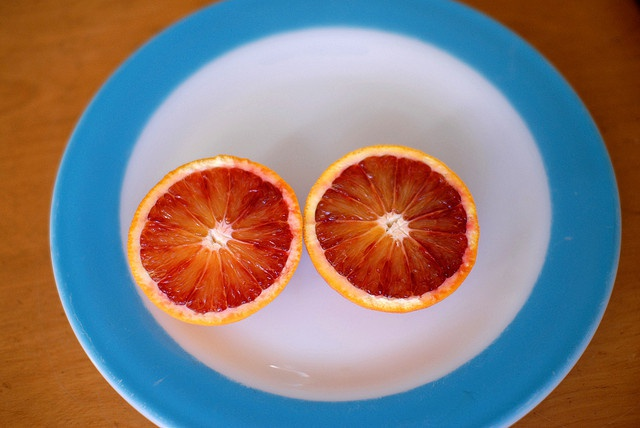Describe the objects in this image and their specific colors. I can see dining table in maroon, brown, and lavender tones, orange in maroon, brown, red, and salmon tones, and orange in maroon, brown, and red tones in this image. 